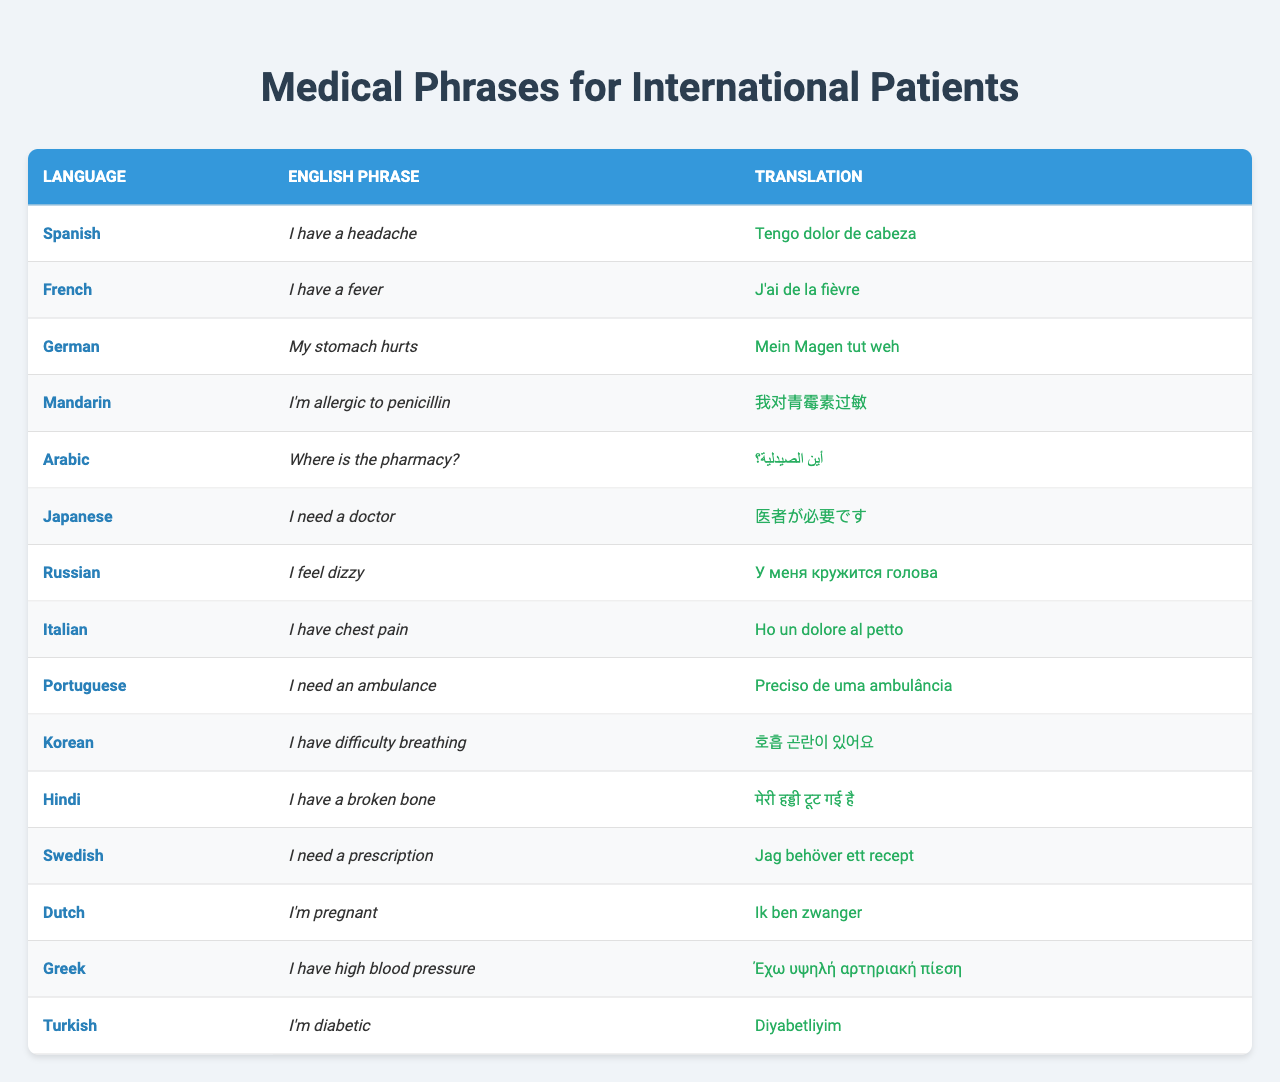What is the Spanish translation for "I have a headache"? The table shows that the English phrase "I have a headache" is translated to Spanish as "Tengo dolor de cabeza".
Answer: Tengo dolor de cabeza Which language translates "I have chest pain" as "Ho un dolore al petto"? Referring to the table, the English phrase "I have chest pain" is translated into Italian as "Ho un dolore al petto".
Answer: Italian Is there a translation for "I'm diabetic" in Russian? Looking at the table, the phrase "I'm diabetic" translates to "Diyabetliyim" in Turkish, not in Russian. There is no corresponding Russian translation for that phrase.
Answer: No How many phrases are translated into Mandarin? The table lists only one phrase "I'm allergic to penicillin" translated into Mandarin, which implies there is just one.
Answer: 1 What is the English phrase that translates to "أين الصيدلية؟" in Arabic? The Arabic phrase "أين الصيدلية؟" corresponds to the English question "Where is the pharmacy?" as indicated in the table.
Answer: Where is the pharmacy? Which language has the same phrase for both “I need a prescription” and “I have a fever”? The table shows that "I need a prescription" is translated as "Jag behöver ett recept" in Swedish, and "I have a fever" is translated as "J'ai de la fièvre" in French, which are different languages, so there is none that shares the same phrase.
Answer: None What are the phrases that mention urgent medical needs? The phrases that indicate urgent medical needs are "I need a doctor", "I need an ambulance", and "I'm allergic to penicillin." These phrases are found under Japanese, Portuguese, and Mandarin respectively.
Answer: 3 Which language has a phrase for "I feel dizzy"? The table indicates that "I feel dizzy" translates into Russian as "У меня кружится голова."
Answer: Russian What is the difference in the translations between "I have a fever" and "I have high blood pressure"? The phrase "I have a fever" translates to "J'ai de la fièvre" in French, while "I have high blood pressure" translates to "Έχω υψηλή αρτηριακή πίεση" in Greek. Both are different translations in different languages, thus the phrases are not the same.
Answer: Different In how many languages is the phrase "I have difficulty breathing" available? The table features the phrase "I have difficulty breathing" only in Korean, which means it is only available in one language.
Answer: 1 